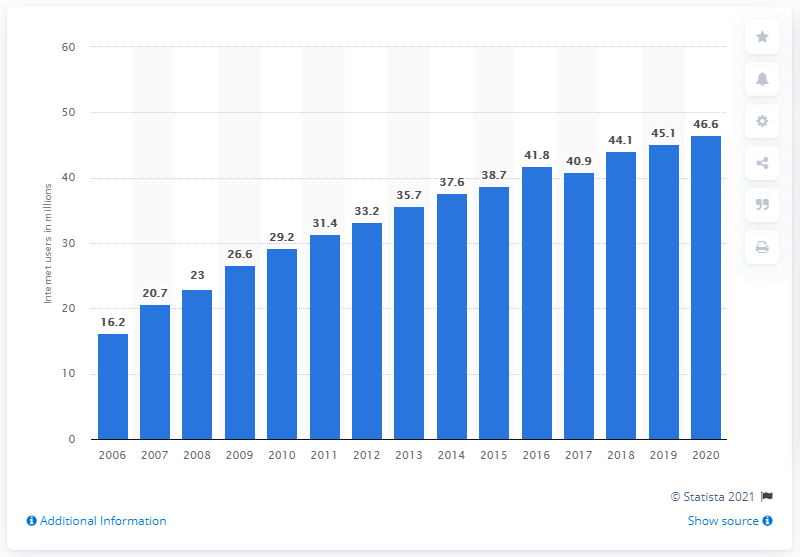Draw attention to some important aspects in this diagram. In 2020, it was reported that 46.6% of people in Great Britain used the internet on a daily basis. In 2016, approximately 41.8% of the population in Great Britain used the internet on a daily basis. 